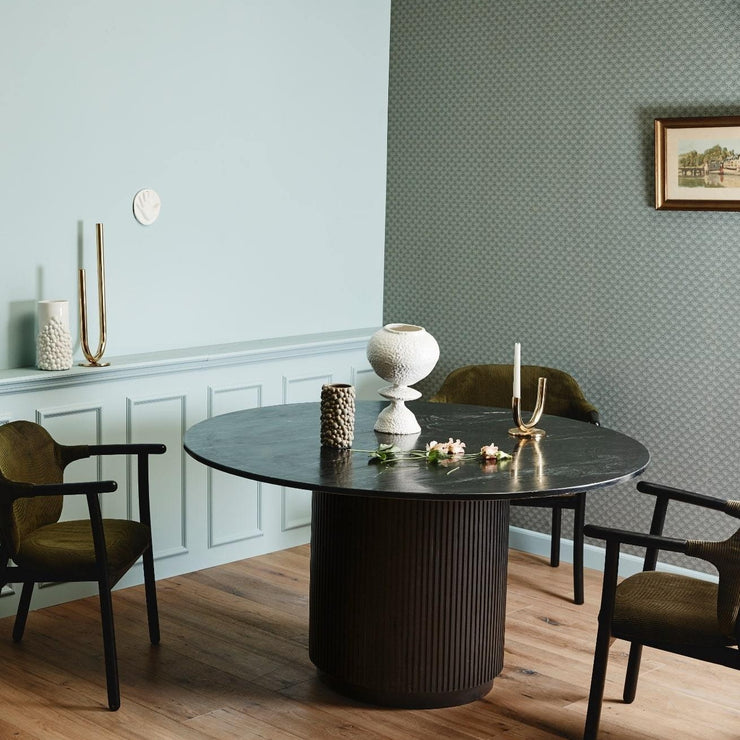Can you suggest an occasion or event that this room might be suitably decorated for? The room's elegant and understated decor would be fitting for a variety of occasions, including a sophisticated dinner party, a celebratory brunch, or even a small, intimate wedding reception. The decor's versatility allows for customization to suit the desired ambience of different events. 